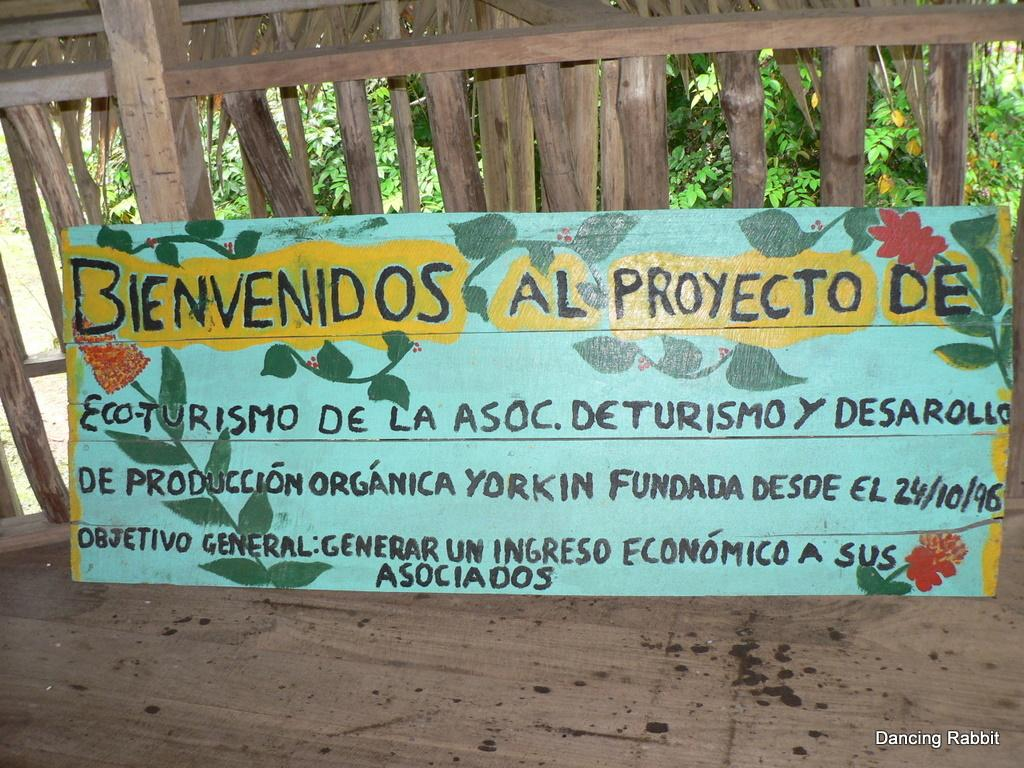What is on the board that is visible in the image? There is text on the board in the image. Where is the board located in the image? The board is on a wooden floor in the image. What can be seen in the background of the image? Trees are visible in the background of the image. What type of vegetation is on the backside of the wall in the image? There are plants on the backside of the wall in the image. What type of farm animals can be seen in the image? There are no farm animals present in the image. What room is the board located in the image? The provided facts do not specify the room or location of the board in the image. 